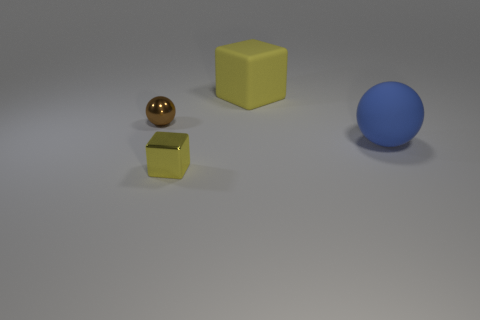Add 2 rubber cubes. How many objects exist? 6 Subtract 1 blue spheres. How many objects are left? 3 Subtract all gray matte cylinders. Subtract all large rubber spheres. How many objects are left? 3 Add 3 blue rubber balls. How many blue rubber balls are left? 4 Add 4 cyan matte balls. How many cyan matte balls exist? 4 